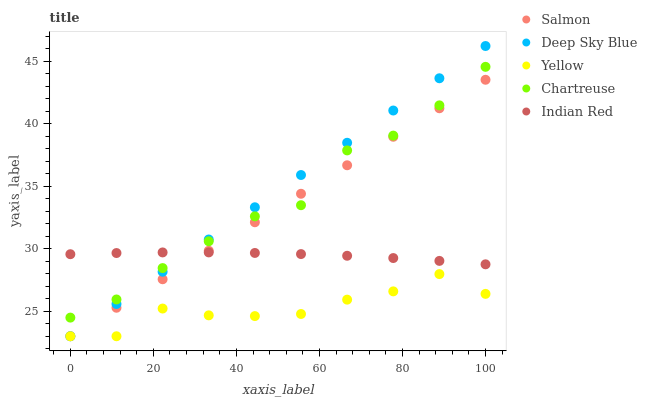Does Yellow have the minimum area under the curve?
Answer yes or no. Yes. Does Deep Sky Blue have the maximum area under the curve?
Answer yes or no. Yes. Does Chartreuse have the minimum area under the curve?
Answer yes or no. No. Does Chartreuse have the maximum area under the curve?
Answer yes or no. No. Is Salmon the smoothest?
Answer yes or no. Yes. Is Chartreuse the roughest?
Answer yes or no. Yes. Is Chartreuse the smoothest?
Answer yes or no. No. Is Salmon the roughest?
Answer yes or no. No. Does Salmon have the lowest value?
Answer yes or no. Yes. Does Chartreuse have the lowest value?
Answer yes or no. No. Does Deep Sky Blue have the highest value?
Answer yes or no. Yes. Does Chartreuse have the highest value?
Answer yes or no. No. Is Yellow less than Chartreuse?
Answer yes or no. Yes. Is Chartreuse greater than Yellow?
Answer yes or no. Yes. Does Deep Sky Blue intersect Indian Red?
Answer yes or no. Yes. Is Deep Sky Blue less than Indian Red?
Answer yes or no. No. Is Deep Sky Blue greater than Indian Red?
Answer yes or no. No. Does Yellow intersect Chartreuse?
Answer yes or no. No. 